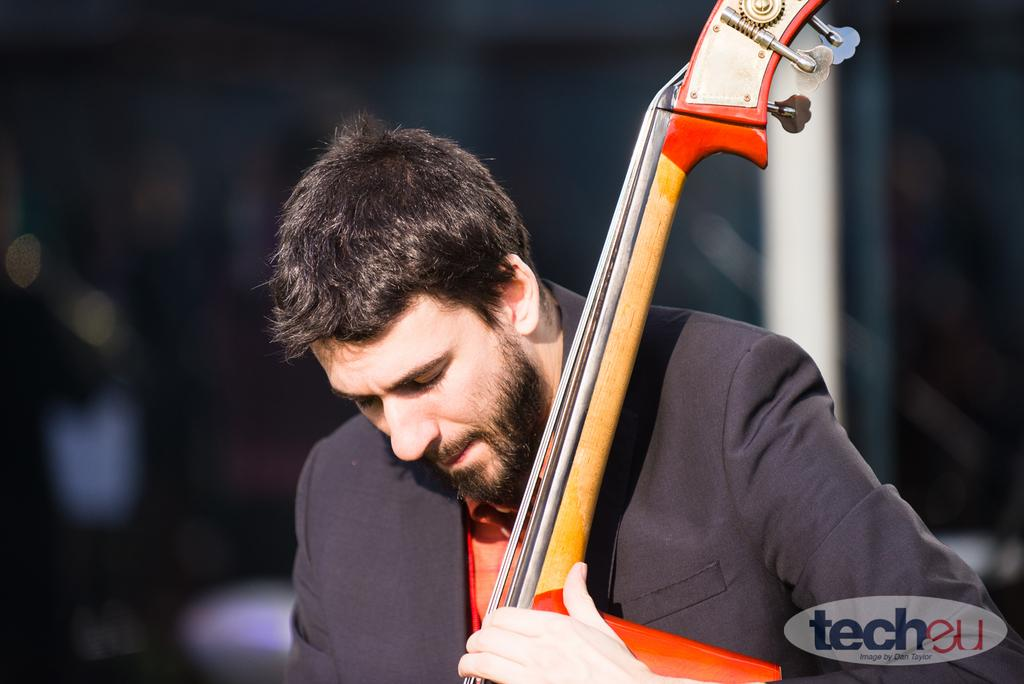What is the main subject of the image? There is a person playing a guitar in the image. Can you describe the background of the image? The background of the image is blurred. What is present at the bottom of the image? There is a logo with text at the bottom of the image. What type of coal is being used by the person playing the guitar in the image? There is no coal present in the image; the person is playing a guitar, not using coal. What color is the yarn that the person playing the guitar is wearing in the image? There is no yarn visible in the image; the person is wearing clothing, but no yarn is mentioned in the provided facts. 